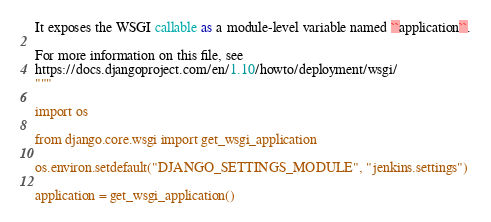Convert code to text. <code><loc_0><loc_0><loc_500><loc_500><_Python_>
It exposes the WSGI callable as a module-level variable named ``application``.

For more information on this file, see
https://docs.djangoproject.com/en/1.10/howto/deployment/wsgi/
"""

import os

from django.core.wsgi import get_wsgi_application

os.environ.setdefault("DJANGO_SETTINGS_MODULE", "jenkins.settings")

application = get_wsgi_application()
</code> 